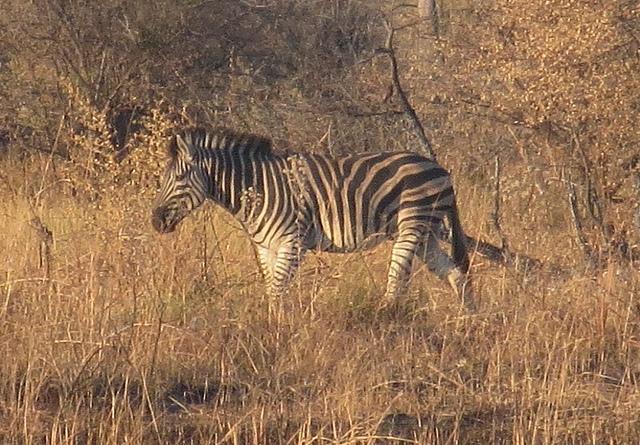How many animals are here?
Give a very brief answer. 1. How many animals are standing up?
Give a very brief answer. 1. 